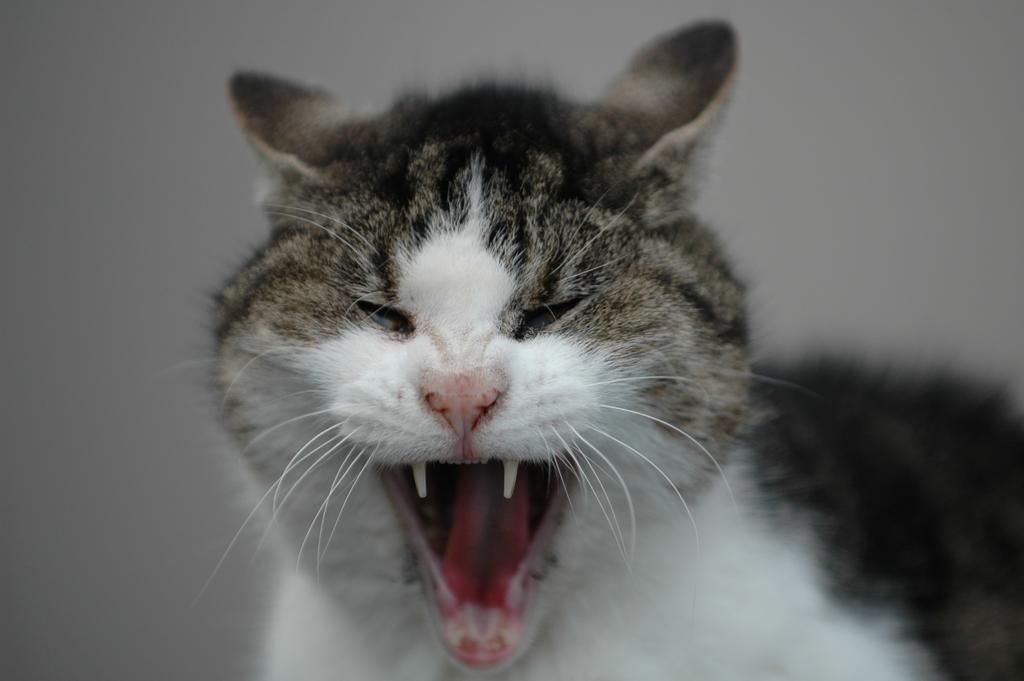In one or two sentences, can you explain what this image depicts? The picture consists of a cat. The edges are blurred. 